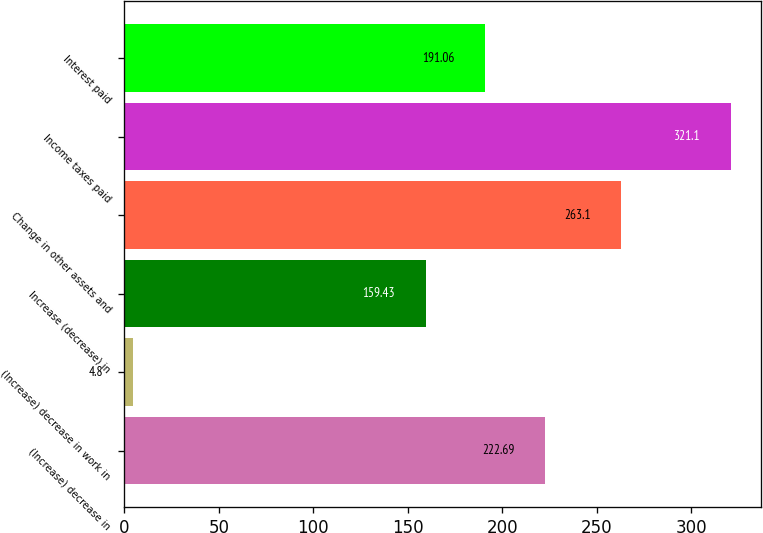<chart> <loc_0><loc_0><loc_500><loc_500><bar_chart><fcel>(Increase) decrease in<fcel>(Increase) decrease in work in<fcel>Increase (decrease) in<fcel>Change in other assets and<fcel>Income taxes paid<fcel>Interest paid<nl><fcel>222.69<fcel>4.8<fcel>159.43<fcel>263.1<fcel>321.1<fcel>191.06<nl></chart> 